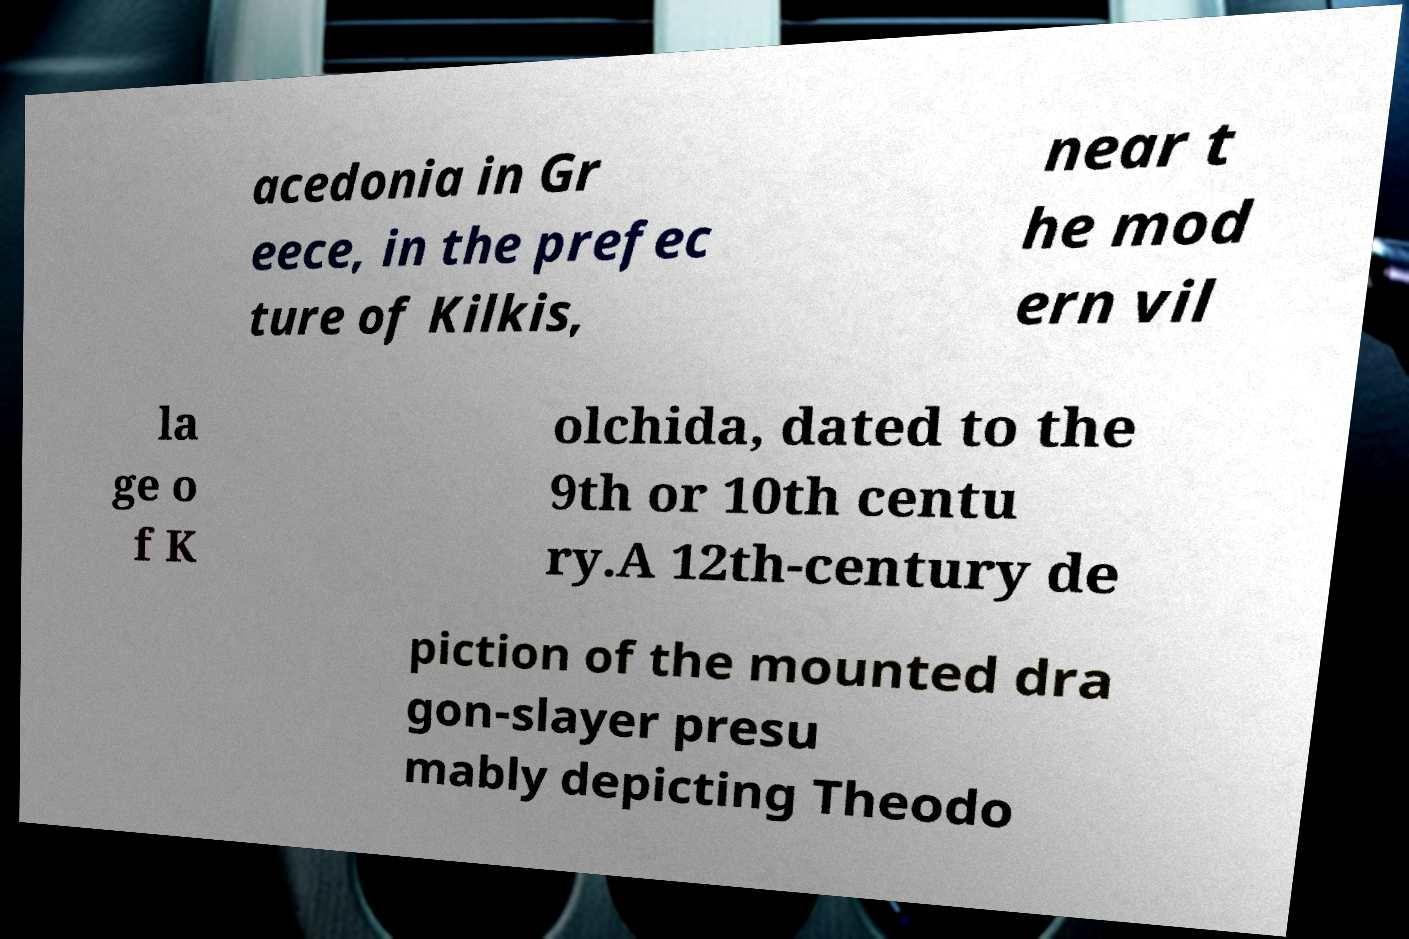Please identify and transcribe the text found in this image. acedonia in Gr eece, in the prefec ture of Kilkis, near t he mod ern vil la ge o f K olchida, dated to the 9th or 10th centu ry.A 12th-century de piction of the mounted dra gon-slayer presu mably depicting Theodo 